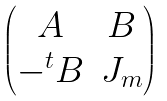Convert formula to latex. <formula><loc_0><loc_0><loc_500><loc_500>\begin{pmatrix} A & B \\ - ^ { t } B & J _ { m } \end{pmatrix}</formula> 